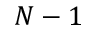Convert formula to latex. <formula><loc_0><loc_0><loc_500><loc_500>N - 1</formula> 